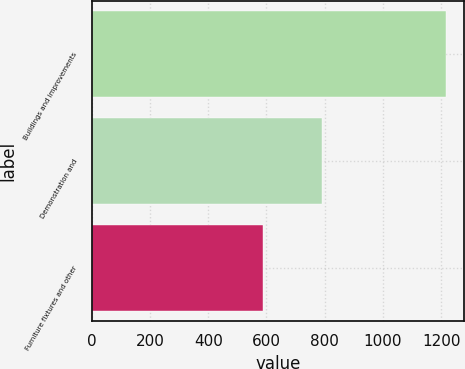Convert chart. <chart><loc_0><loc_0><loc_500><loc_500><bar_chart><fcel>Buildings and improvements<fcel>Demonstration and<fcel>Furniture fixtures and other<nl><fcel>1217<fcel>792<fcel>589<nl></chart> 